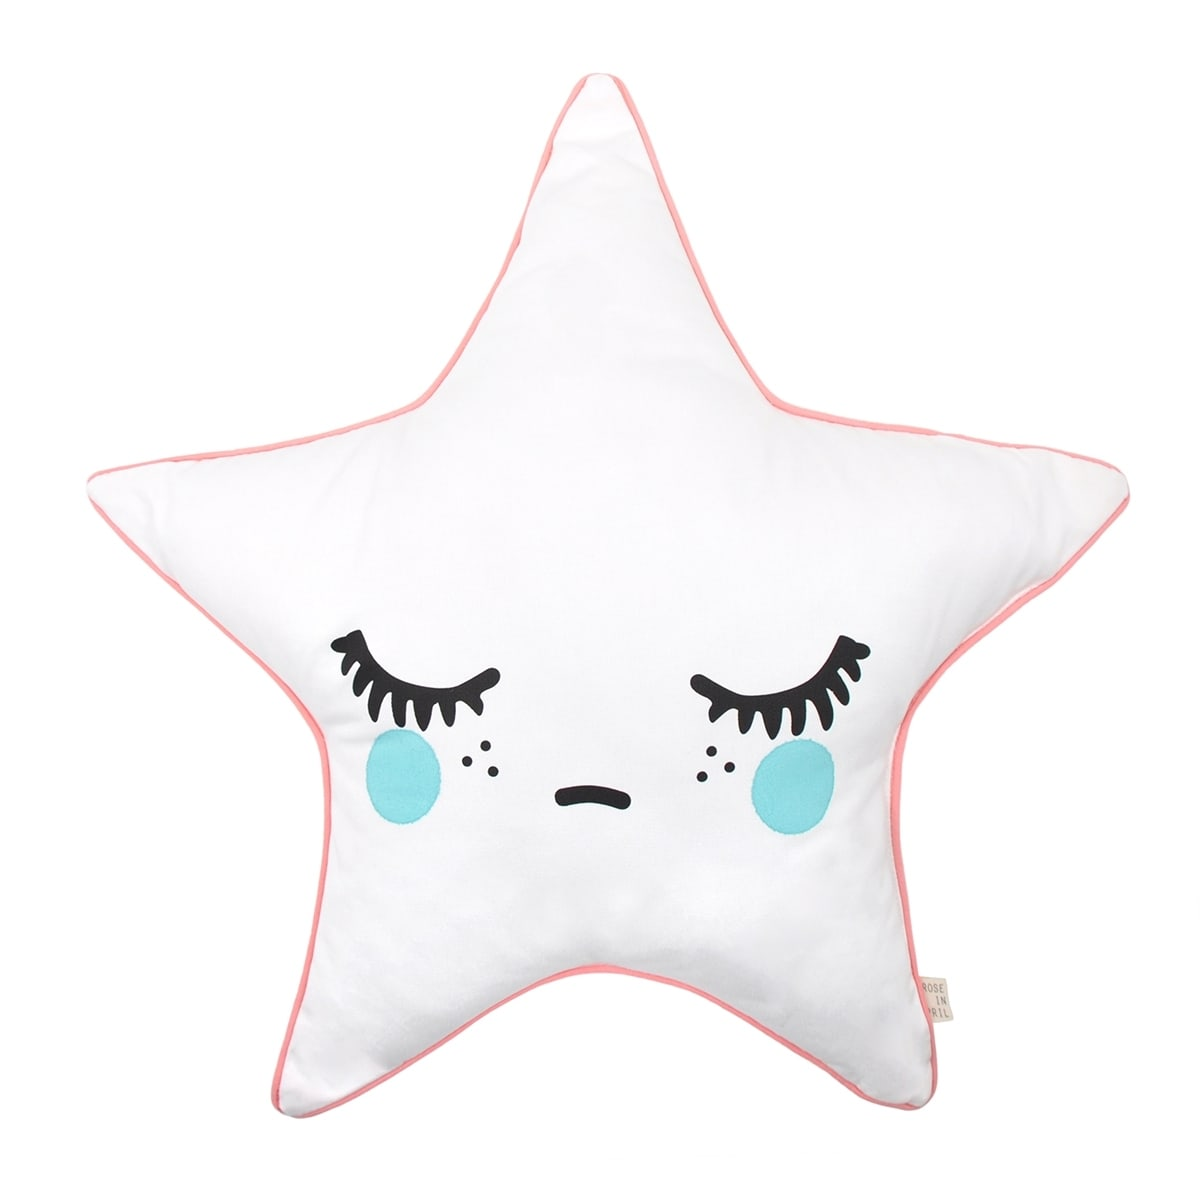Can you describe the emotions this pillow design might evoke when seen in a child's bedroom? The design of this pillow, with its soft star shape and sleepy facial expression, likely evokes a sense of calmness and comfort. In a child's bedroom, it could create a soothing and safe atmosphere, encouraging relaxation and a sense of security. The playful and whimsical aesthetic might also spark a child's imagination and add a touch of delight and enchantment to their personal space. Overall, it would contribute to a warm and inviting environment, ideal for restful sleep and cozy moments. 